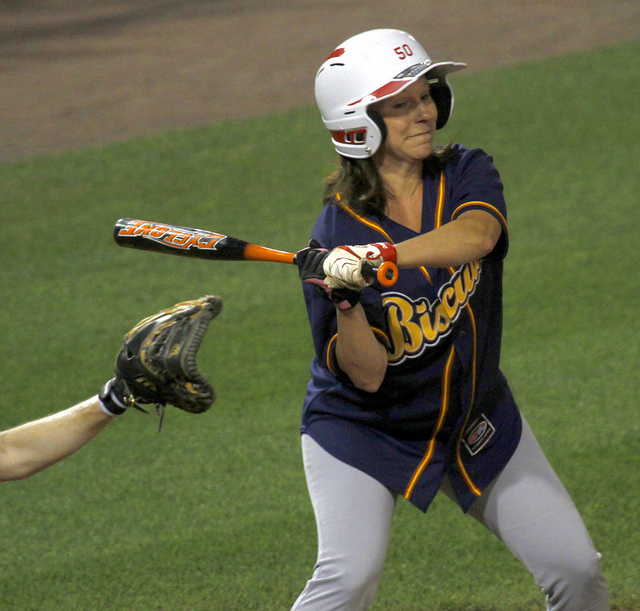Please transcribe the text in this image. CYCLONE Biscu 50 